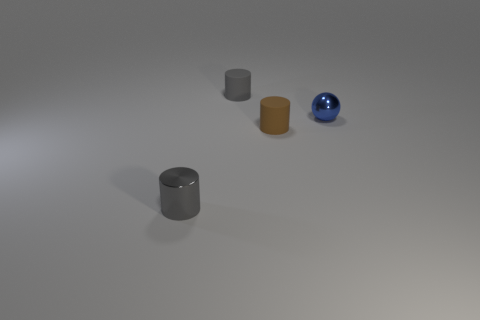Subtract all gray cylinders. How many were subtracted if there are1gray cylinders left? 1 Add 2 tiny gray rubber objects. How many objects exist? 6 Subtract all cylinders. How many objects are left? 1 Add 2 rubber cylinders. How many rubber cylinders exist? 4 Subtract 0 yellow cubes. How many objects are left? 4 Subtract all tiny gray shiny things. Subtract all tiny gray cylinders. How many objects are left? 1 Add 4 gray cylinders. How many gray cylinders are left? 6 